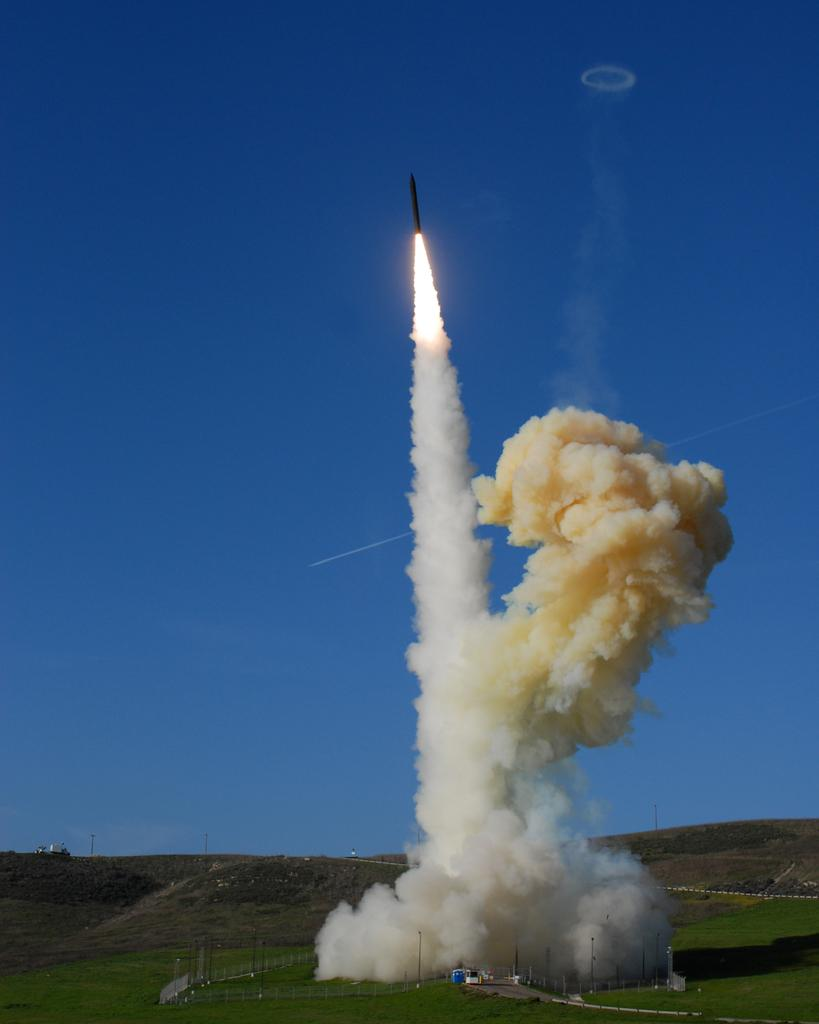What is the main subject of the image? There is a rocket in the image. What is the rocket doing in the image? The rocket is flying into the air. What can be seen at the bottom of the image? There is smoke at the bottom of the image. What type of landscape is visible in the image? There are hills visible in the image, and there is grass present. What type of island can be seen in the image? There is no island present in the image; it features a rocket flying into the air with smoke at the bottom and a landscape of hills and grass. What sound does the rocket make as it flies into the air? The image is silent, so it is not possible to determine the sound of the rocket from the image. 